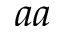Convert formula to latex. <formula><loc_0><loc_0><loc_500><loc_500>a a</formula> 